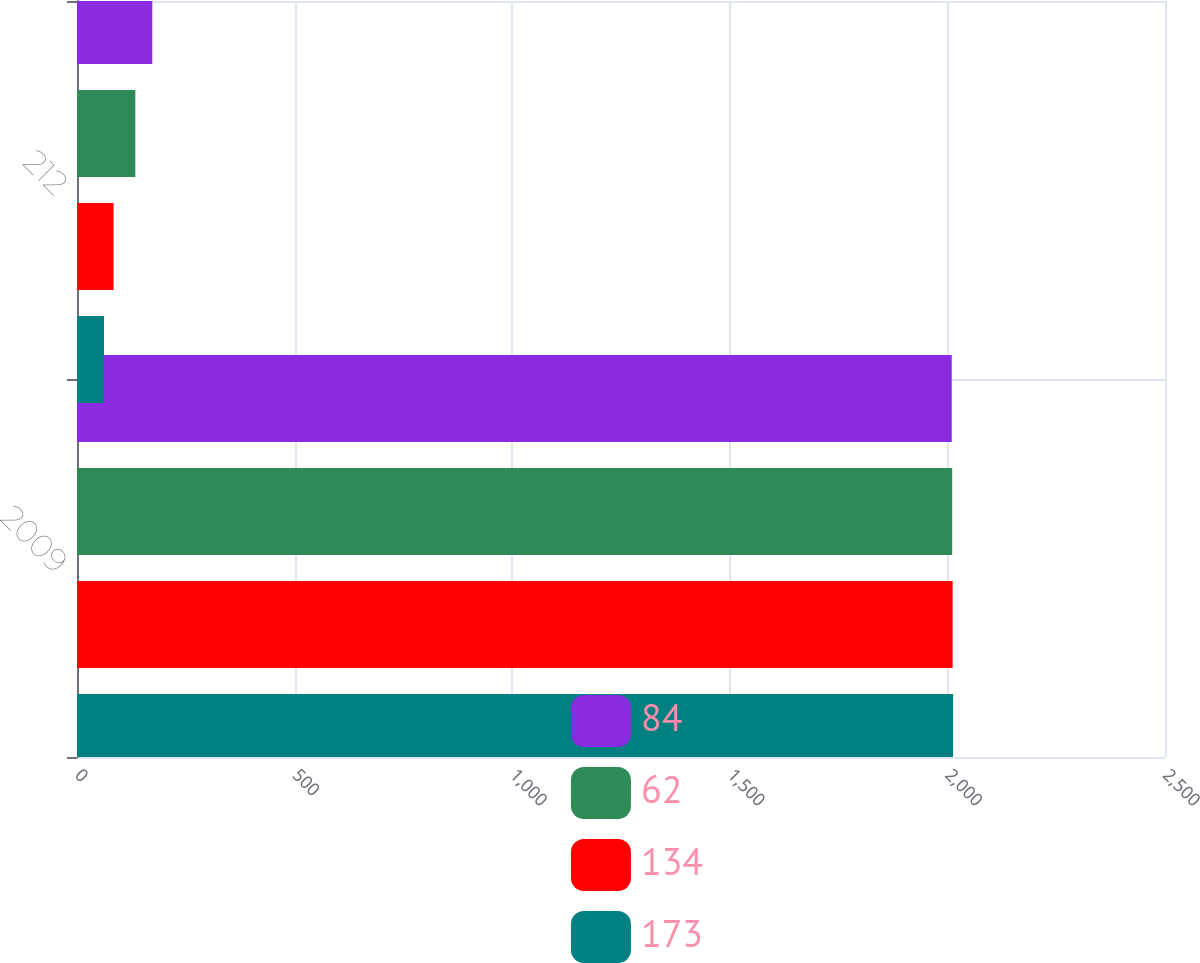<chart> <loc_0><loc_0><loc_500><loc_500><stacked_bar_chart><ecel><fcel>2009<fcel>212<nl><fcel>84<fcel>2010<fcel>173<nl><fcel>62<fcel>2011<fcel>134<nl><fcel>134<fcel>2012<fcel>84<nl><fcel>173<fcel>2013<fcel>62<nl></chart> 